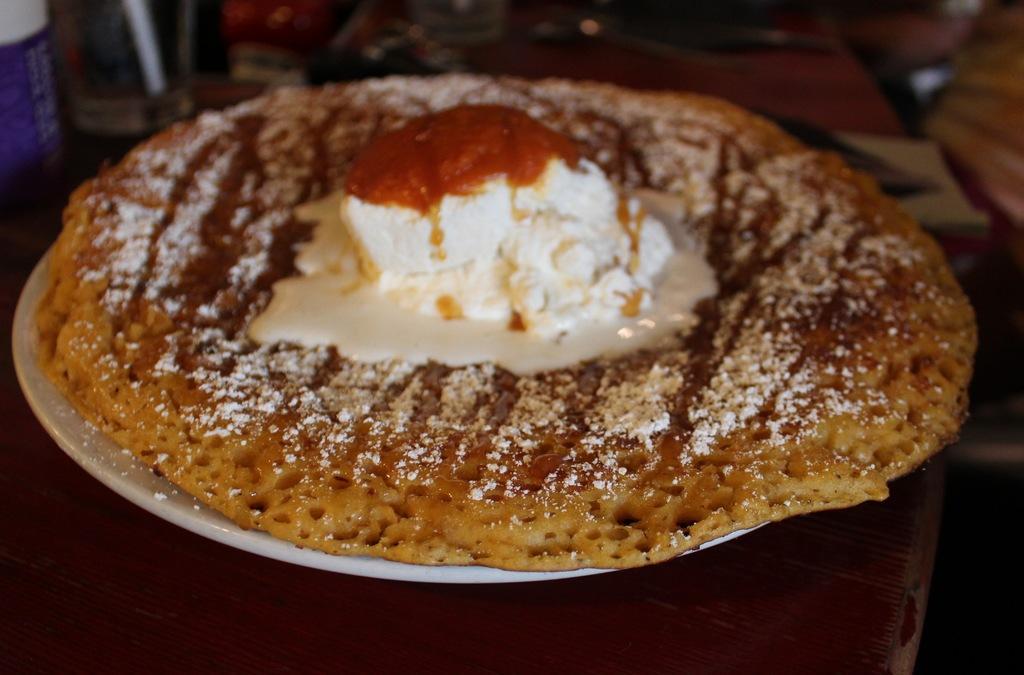Can you describe this image briefly? In this image in front there is a food item in a plate which was placed on the table. We can also see some other objects on the table. 